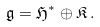<formula> <loc_0><loc_0><loc_500><loc_500>\mathfrak { g } = \mathfrak { H } ^ { * } \oplus \mathfrak { K } \, .</formula> 